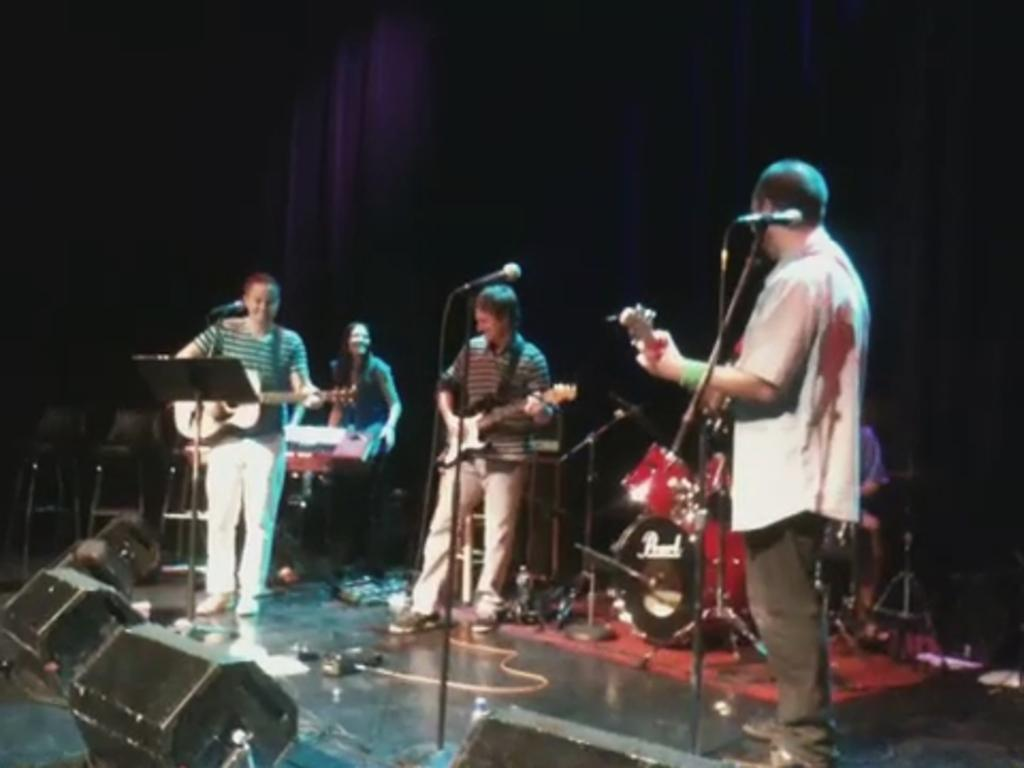What are the persons on stage doing? The persons on stage are playing guitar. What musical instruments are visible behind the persons? There is a drum kit and a piano behind the persons. What is the color of the background in the image? The background of the image is dark. Can you see any lace on the persons playing guitar in the image? There is no mention of lace in the image, and it is not visible in the provided facts. 